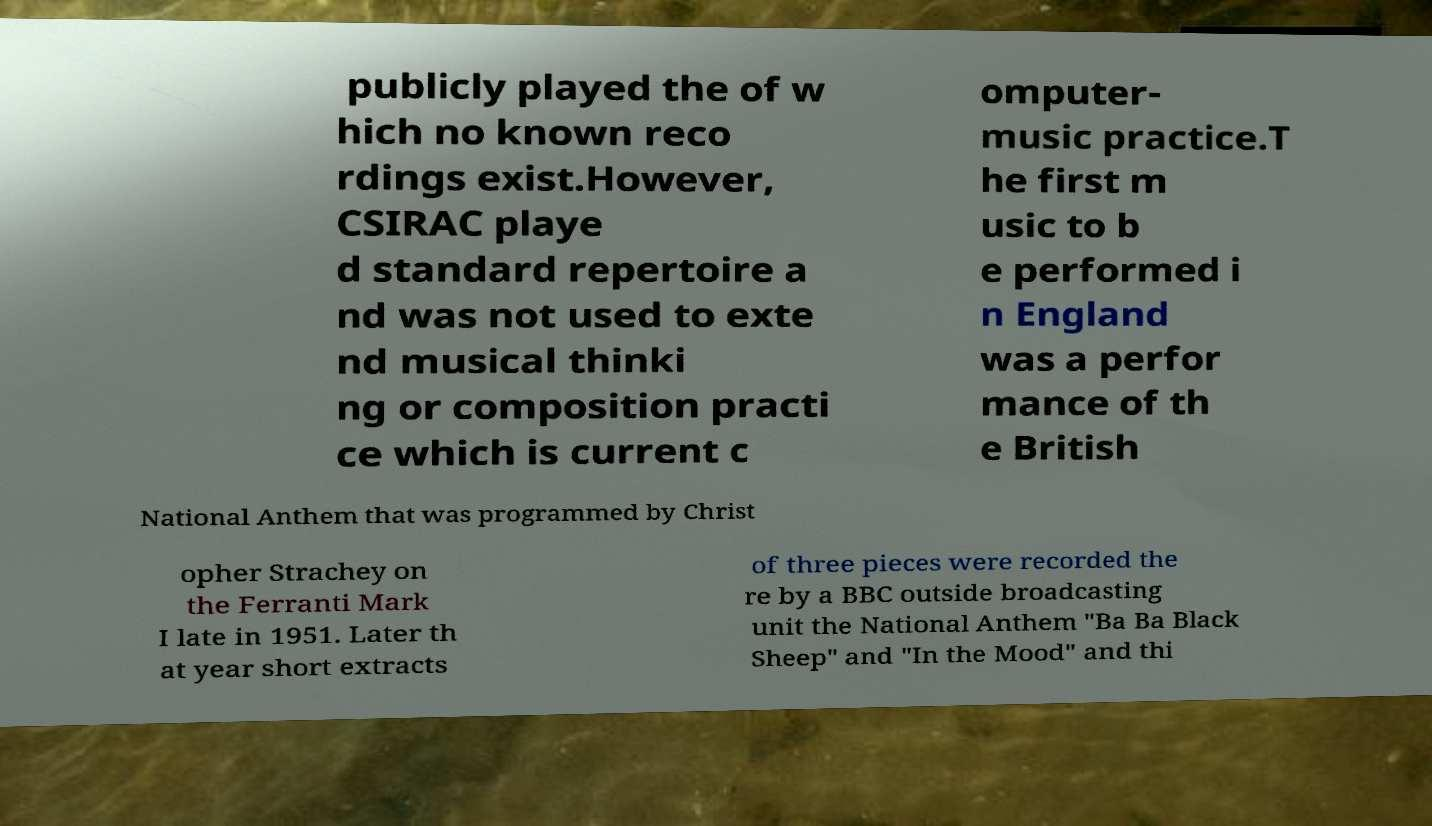Can you read and provide the text displayed in the image?This photo seems to have some interesting text. Can you extract and type it out for me? publicly played the of w hich no known reco rdings exist.However, CSIRAC playe d standard repertoire a nd was not used to exte nd musical thinki ng or composition practi ce which is current c omputer- music practice.T he first m usic to b e performed i n England was a perfor mance of th e British National Anthem that was programmed by Christ opher Strachey on the Ferranti Mark I late in 1951. Later th at year short extracts of three pieces were recorded the re by a BBC outside broadcasting unit the National Anthem "Ba Ba Black Sheep" and "In the Mood" and thi 